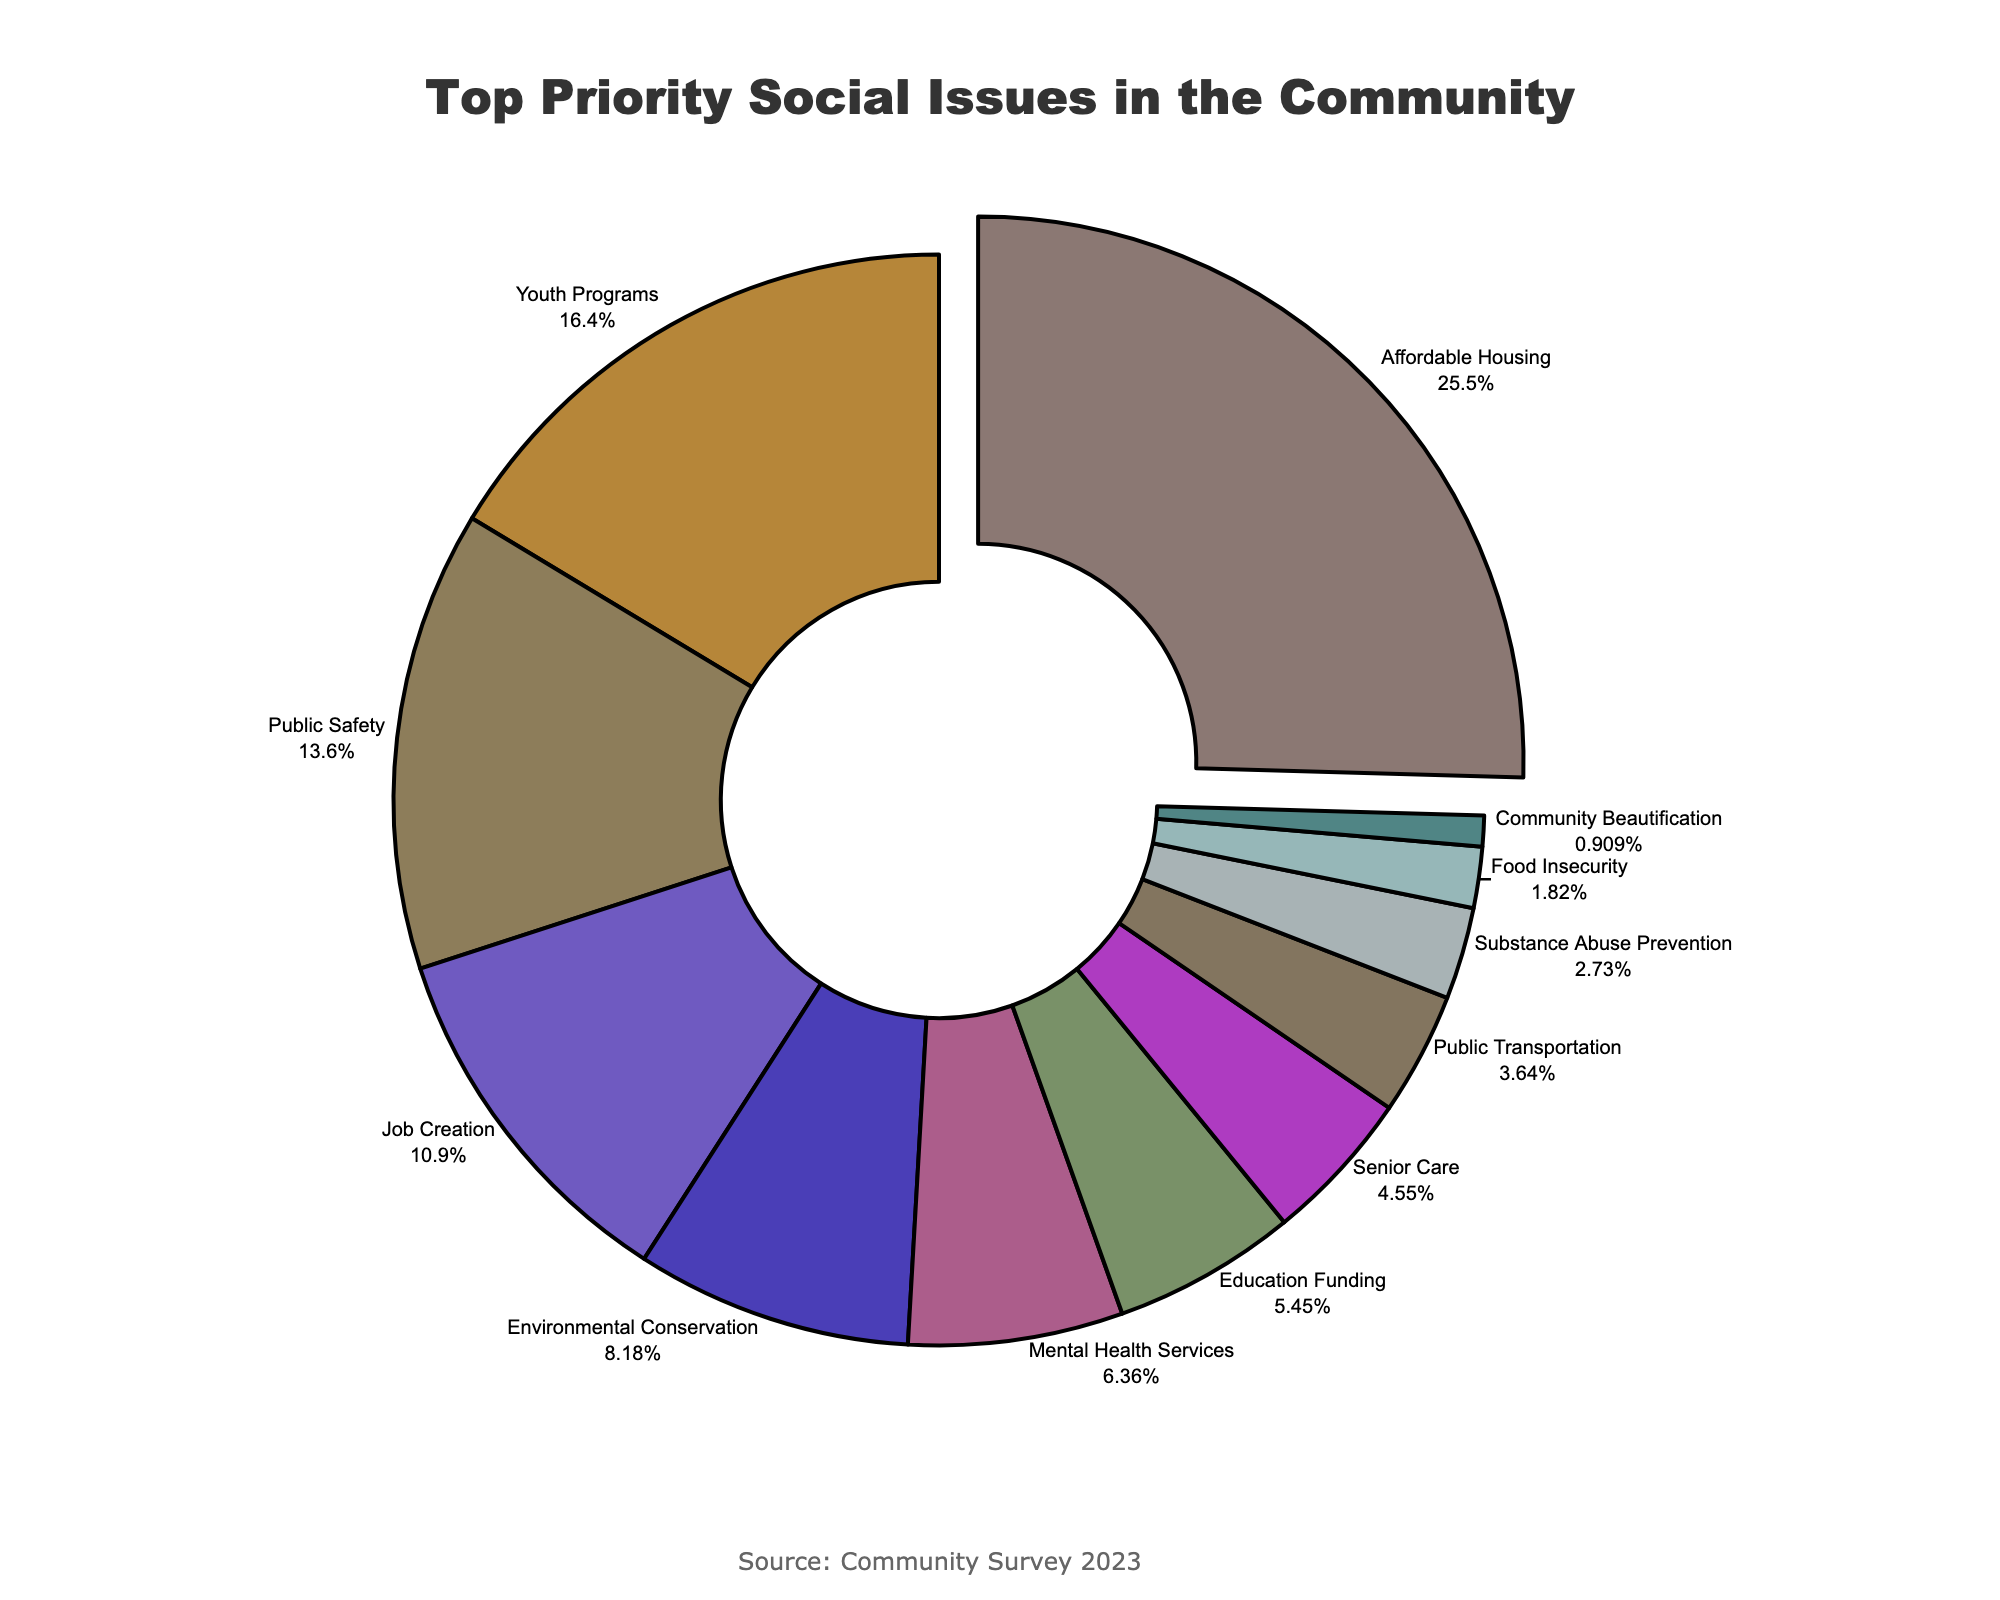What's the most identified top priority social issue by community members? By looking at the pie chart, the slice with the largest percentage represents the most identified top priority social issue. From the chart, Affordable Housing is the issue with the largest percentage at 28%.
Answer: Affordable Housing Which two social issues combined have a lower priority than Youth Programs? Youth Programs has a percentage of 18%. We need to identify two issues whose combined percentages are less than 18%. From the chart, Senior Care (5%) and Public Transportation (4%) combined make 9%, which is less than 18%.
Answer: Senior Care and Public Transportation How does the community prioritize Mental Health Services compared to Public Safety? To compare, we look at the slices for Mental Health Services and Public Safety. Mental Health Services has 7% while Public Safety has 15%. Thus, Public Safety is prioritized higher than Mental Health Services.
Answer: Public Safety is prioritized higher What is the total percentage of environmental and educational issues combined? By adding the percentages of Environmental Conservation and Education Funding shown in the chart, we get 9% (Environmental Conservation) + 6% (Education Funding) = 15%.
Answer: 15% Which issue has the smallest identified priority? The smallest slice on the pie chart indicates the issue with the least priority. Community Beautification has the smallest percentage at 1%.
Answer: Community Beautification What percentage of respondents prioritize Job Creation and Education Funding together? Adding the percentages of Job Creation and Education Funding as seen on the pie chart, we get 12% (Job Creation) + 6% (Education Funding) = 18%.
Answer: 18% How does Food Insecurity compare to Substance Abuse Prevention in terms of priority? Comparing the slices for Food Insecurity and Substance Abuse Prevention, Food Insecurity has 2% while Substance Abuse Prevention has 3%. Thus, Substance Abuse Prevention has a slightly higher priority than Food Insecurity.
Answer: Substance Abuse Prevention is prioritized higher 